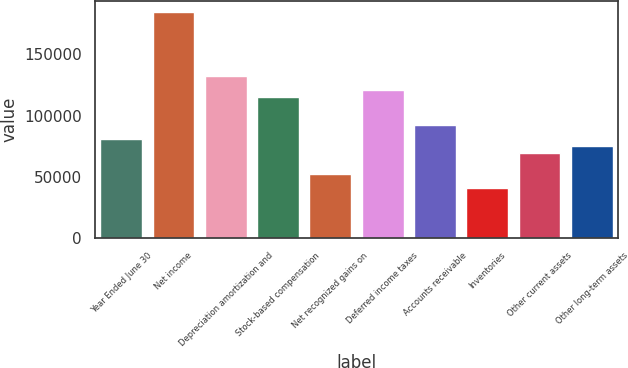Convert chart to OTSL. <chart><loc_0><loc_0><loc_500><loc_500><bar_chart><fcel>Year Ended June 30<fcel>Net income<fcel>Depreciation amortization and<fcel>Stock-based compensation<fcel>Net recognized gains on<fcel>Deferred income taxes<fcel>Accounts receivable<fcel>Inventories<fcel>Other current assets<fcel>Other long-term assets<nl><fcel>80775.4<fcel>184628<fcel>132702<fcel>115393<fcel>51927.4<fcel>121163<fcel>92314.7<fcel>40388.2<fcel>69236.2<fcel>75005.8<nl></chart> 